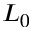Convert formula to latex. <formula><loc_0><loc_0><loc_500><loc_500>L _ { 0 }</formula> 